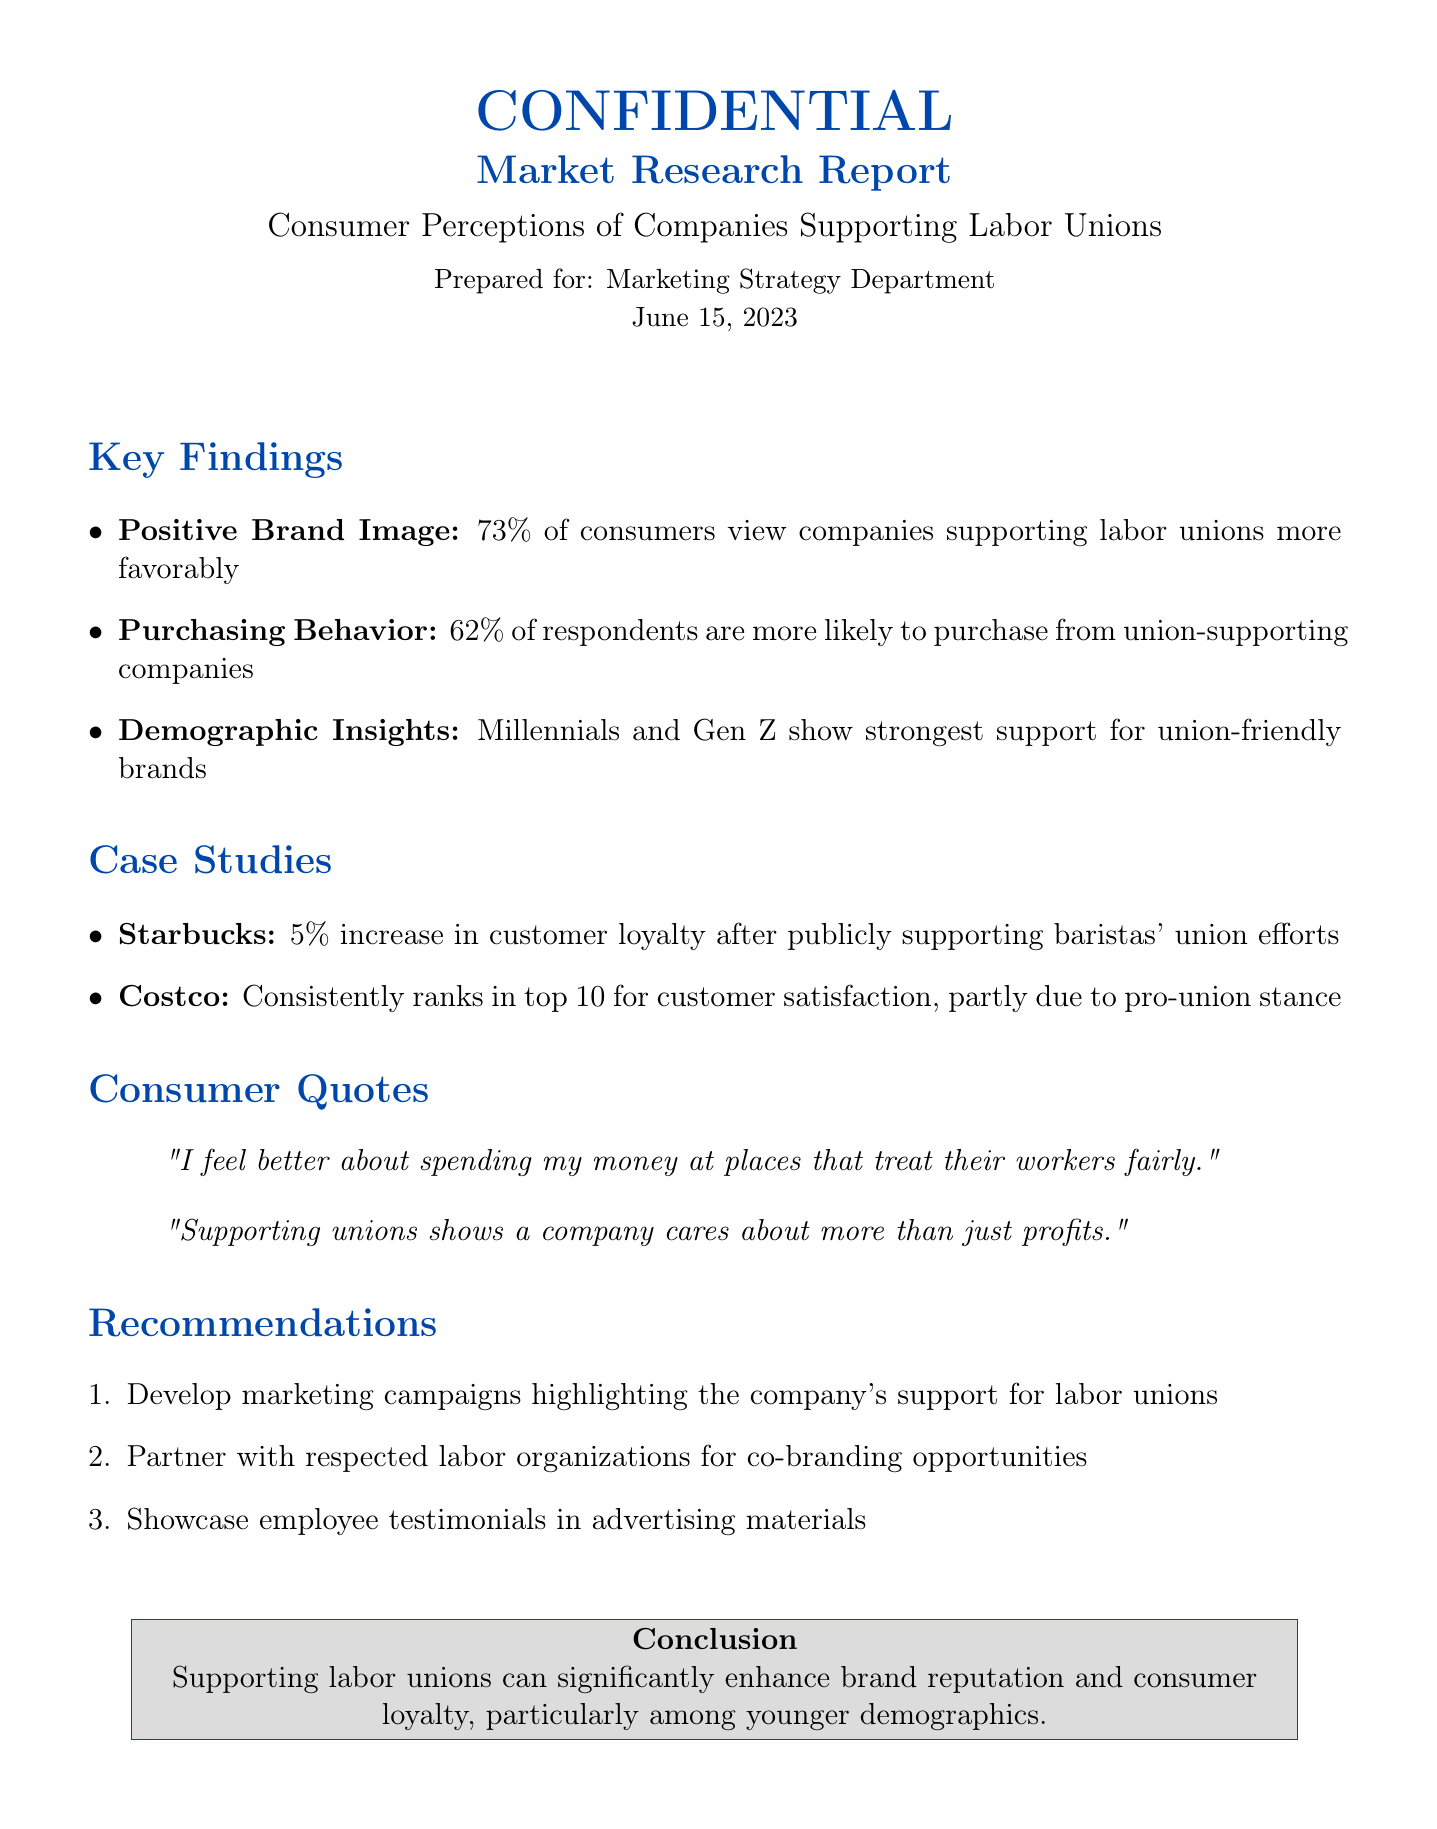What percentage of consumers view companies supporting labor unions more favorably? The document states that 73% of consumers have a favorable view of companies that support labor unions.
Answer: 73% What demographic shows the strongest support for union-friendly brands? According to the document, Millennials and Gen Z are identified as showing the strongest support for union-friendly brands.
Answer: Millennials and Gen Z What was the increase in customer loyalty for Starbucks after supporting union efforts? The document mentions a 5% increase in customer loyalty for Starbucks after their public support for baristas' union efforts.
Answer: 5% What is the primary recommendation given in the report? The first recommendation in the report is to develop marketing campaigns highlighting the company's support for labor unions.
Answer: Develop marketing campaigns highlighting the company's support for labor unions What is one consumer quote mentioned in the report? One consumer quote reflects a positive sentiment towards spending money at places that treat their workers fairly.
Answer: "I feel better about spending my money at places that treat their workers fairly." What is the main conclusion drawn in the document? The conclusion emphasizes that supporting labor unions can significantly enhance brand reputation and consumer loyalty.
Answer: Supporting labor unions can significantly enhance brand reputation and consumer loyalty 